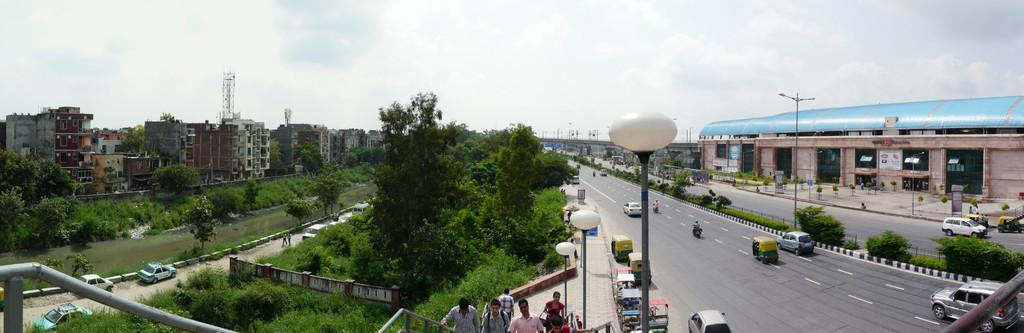What type of structures can be seen in the image? There are many buildings in the image. What type of vegetation is present in the image? There are trees and plants in the image. What type of infrastructure can be seen in the image? There are poles in the image. What type of illumination is present in the image? There are lights in the image. Who or what else can be seen in the image? There are people and vehicles on the road in the image. What is visible at the top of the image? The sky is visible at the top of the image. Where is the prison located in the image? There is no prison present in the image. What type of shade is provided by the trees in the image? The image does not show any specific shade provided by the trees; it only shows the presence of trees. 